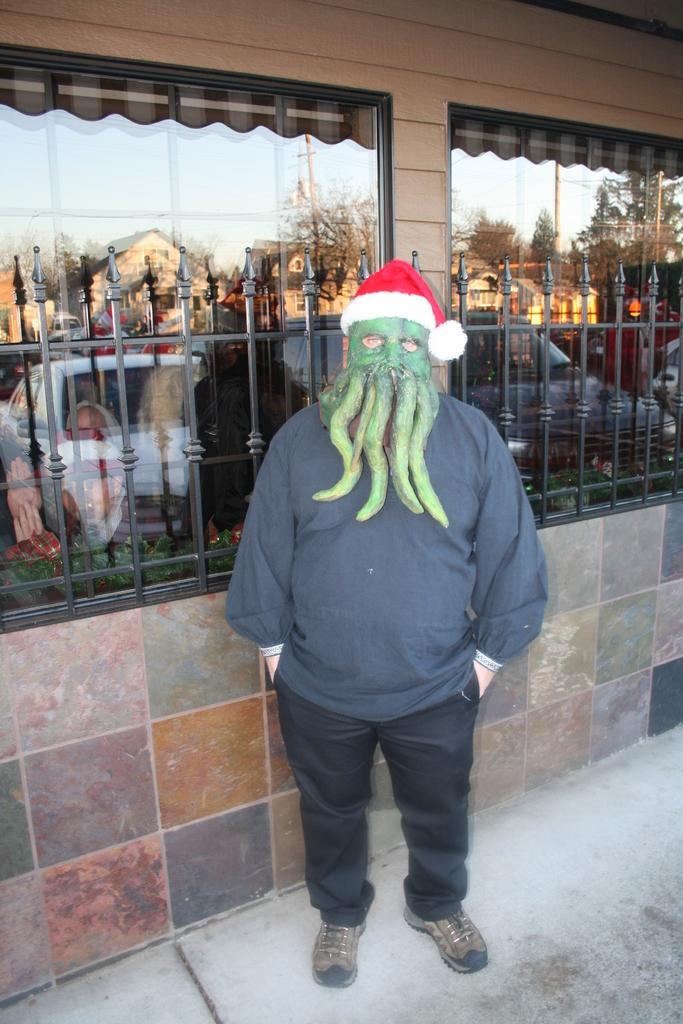What is the person in the image wearing on their face? The person is wearing a mask. What type of headwear is the person wearing in the image? The person is wearing a cap. What can be seen in the background of the image? There is a metal fence and a building with windows in the image. What type of thread is the person using to brush their teeth in the image? There is no toothbrush or thread present in the image. Can you tell me the name of the person's brother in the image? There is: There is no mention of a brother or any other person in the image. 